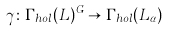<formula> <loc_0><loc_0><loc_500><loc_500>\gamma \colon \Gamma _ { h o l } ( \L L ) ^ { G } \to \Gamma _ { h o l } ( \L L _ { \alpha } )</formula> 